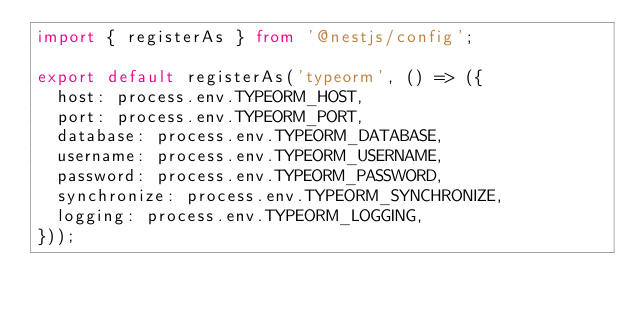<code> <loc_0><loc_0><loc_500><loc_500><_TypeScript_>import { registerAs } from '@nestjs/config';

export default registerAs('typeorm', () => ({
  host: process.env.TYPEORM_HOST,
  port: process.env.TYPEORM_PORT,
  database: process.env.TYPEORM_DATABASE,
  username: process.env.TYPEORM_USERNAME,
  password: process.env.TYPEORM_PASSWORD,
  synchronize: process.env.TYPEORM_SYNCHRONIZE,
  logging: process.env.TYPEORM_LOGGING,
}));
</code> 